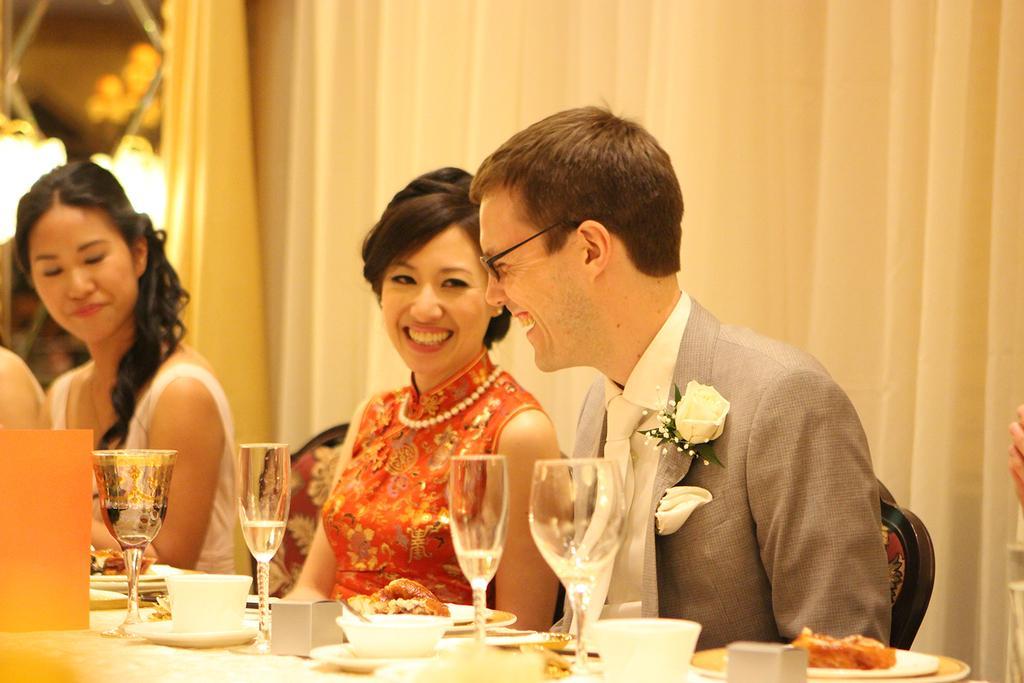In one or two sentences, can you explain what this image depicts? In this image I can see few persons sitting on chairs in front of the table and on the table I can see few cups, few plates, few food items in the plates, few glasses and few other objects. In the background I can see the cream colored curtain, few lights and few other objects. 